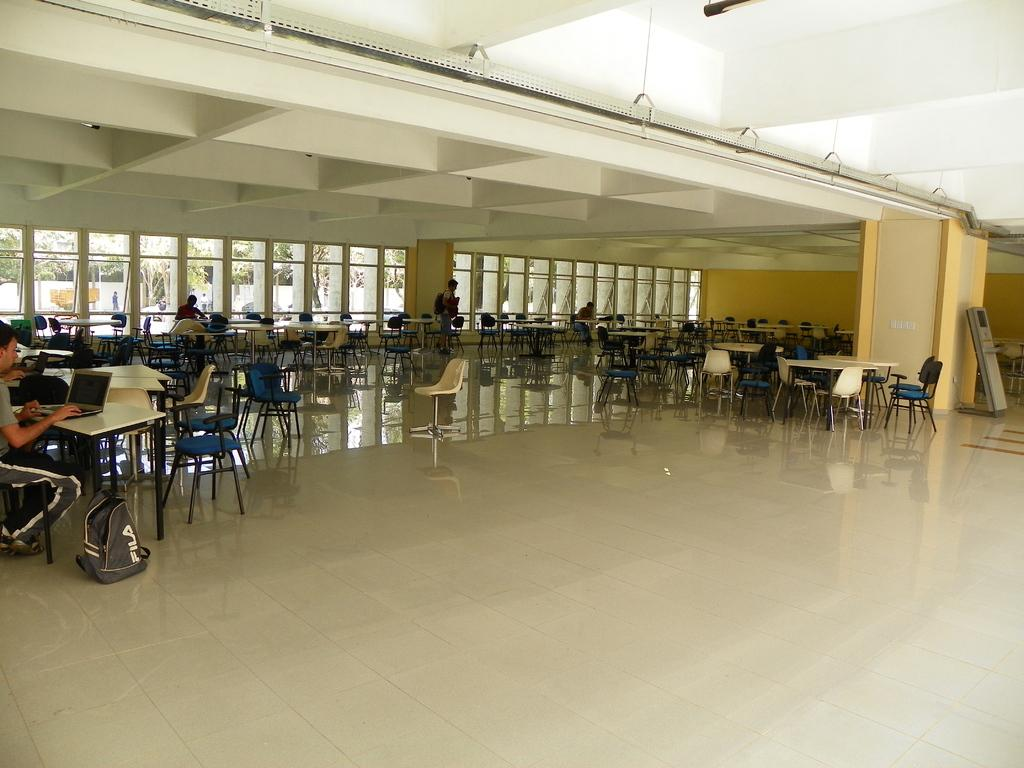What type of space is depicted in the image? There is a hall in the image. Can you describe the person in the image? There is a person sitting on the left side of the image. What is the person doing in the image? The person is using a laptop. What type of honey is being sold in the hall in the image? There is no mention of honey or any type of sale in the image; it simply shows a person sitting and using a laptop in a hall. 